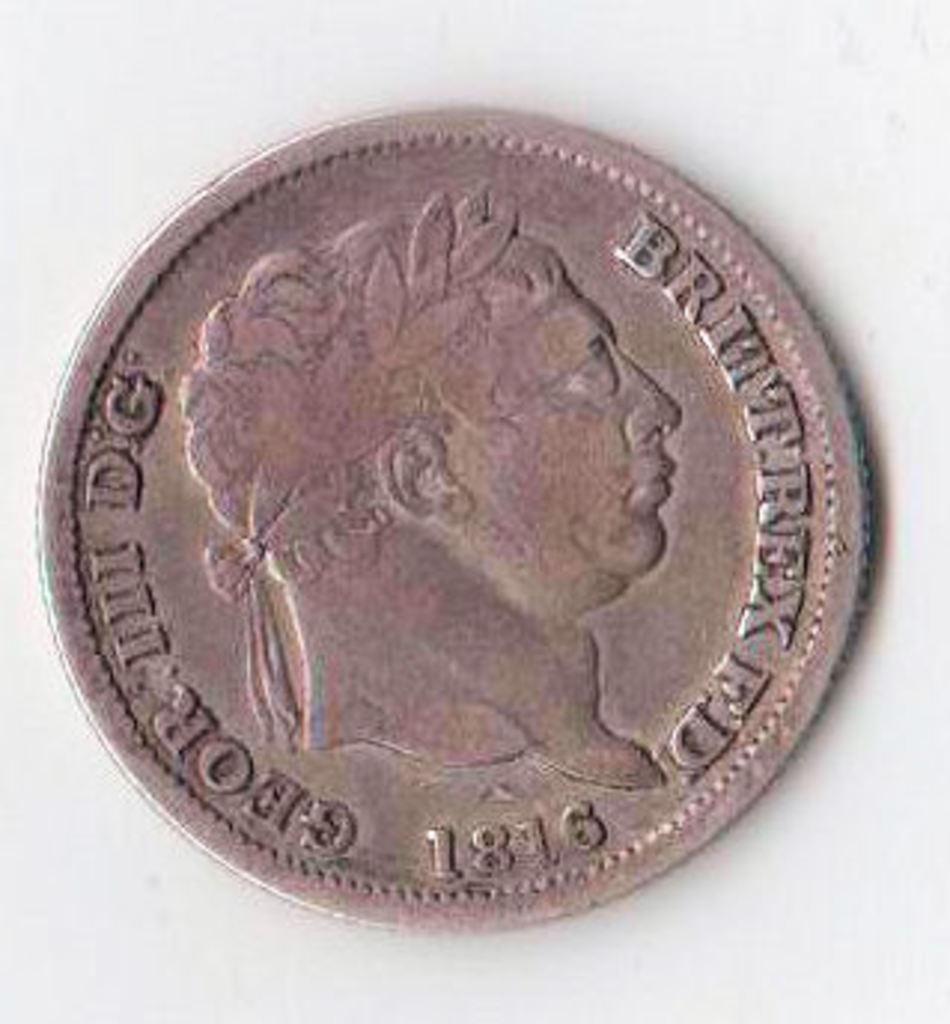Can you describe this image briefly? In this image, this looks like a coin. I can see the image of the man and letters on the coin. The background looks white in color. 